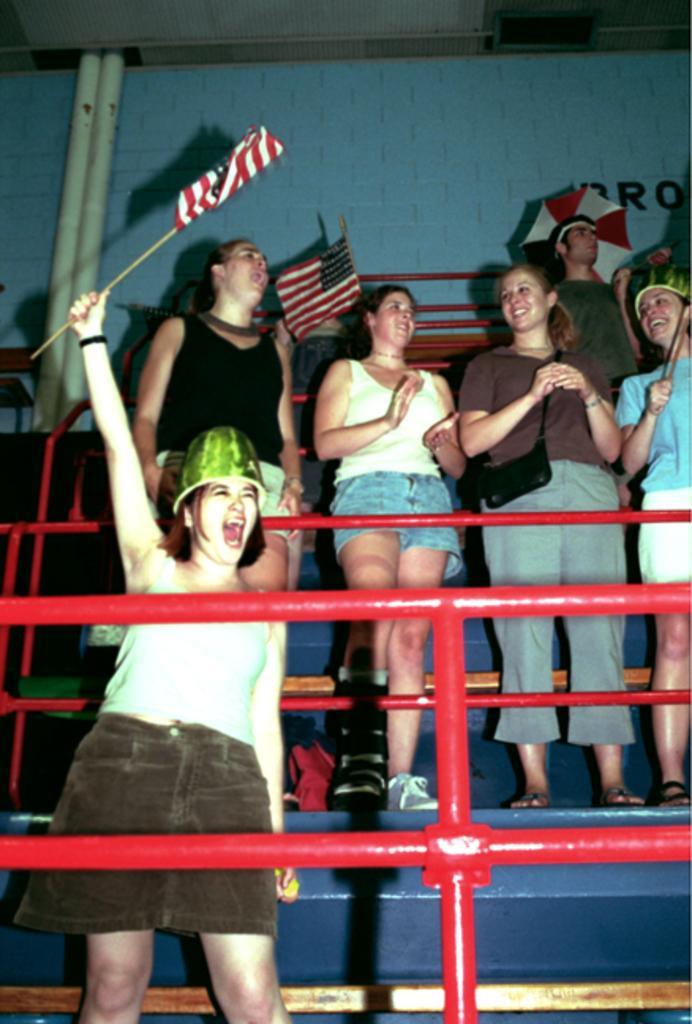Please provide a concise description of this image. In this image I can see there are some persons standing in front of the pipe line and I can see flags and I can see the wall. 